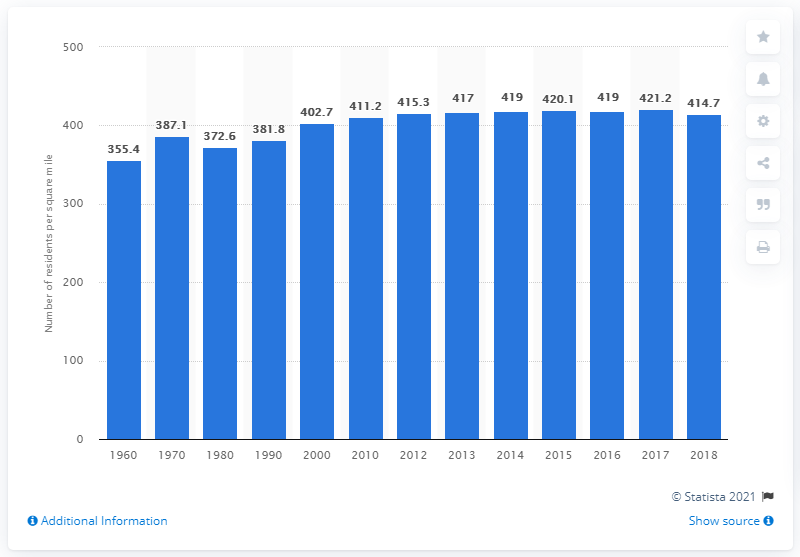List a handful of essential elements in this visual. The population density of New York in 2018 was 414.7 people per square mile. 